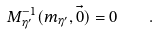Convert formula to latex. <formula><loc_0><loc_0><loc_500><loc_500>M _ { \eta ^ { \prime } } ^ { - 1 } ( m _ { \eta ^ { \prime } } , \vec { 0 } ) = 0 \quad .</formula> 